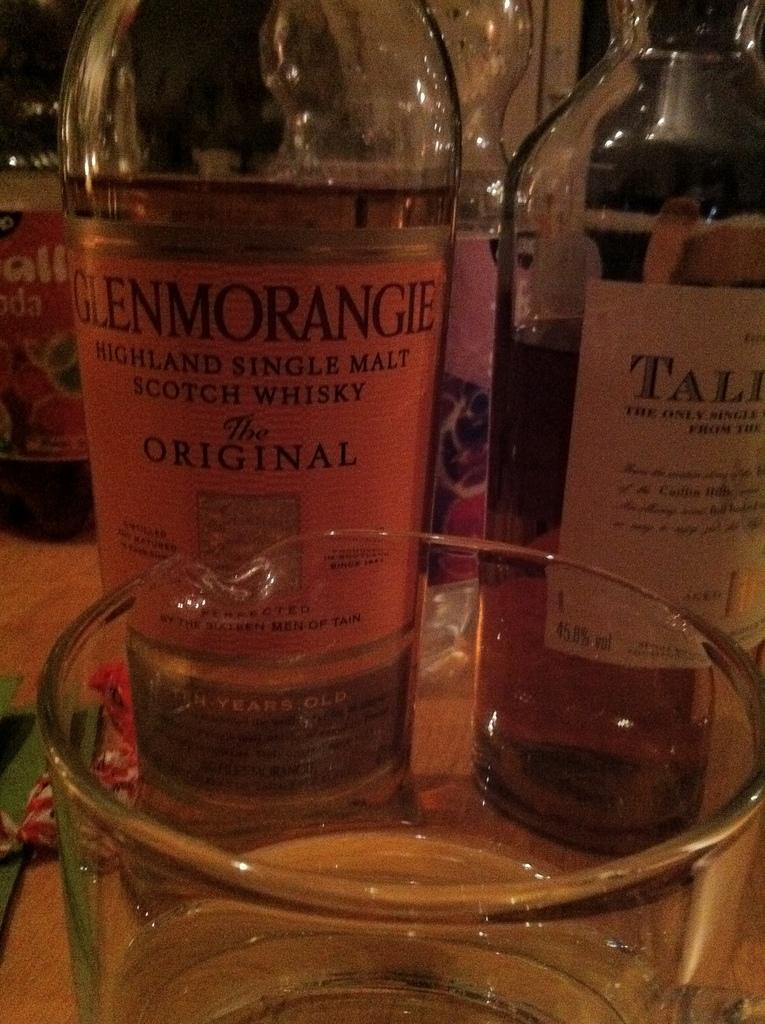<image>
Present a compact description of the photo's key features. A bottle with an orange label reads Glenmorangie. 